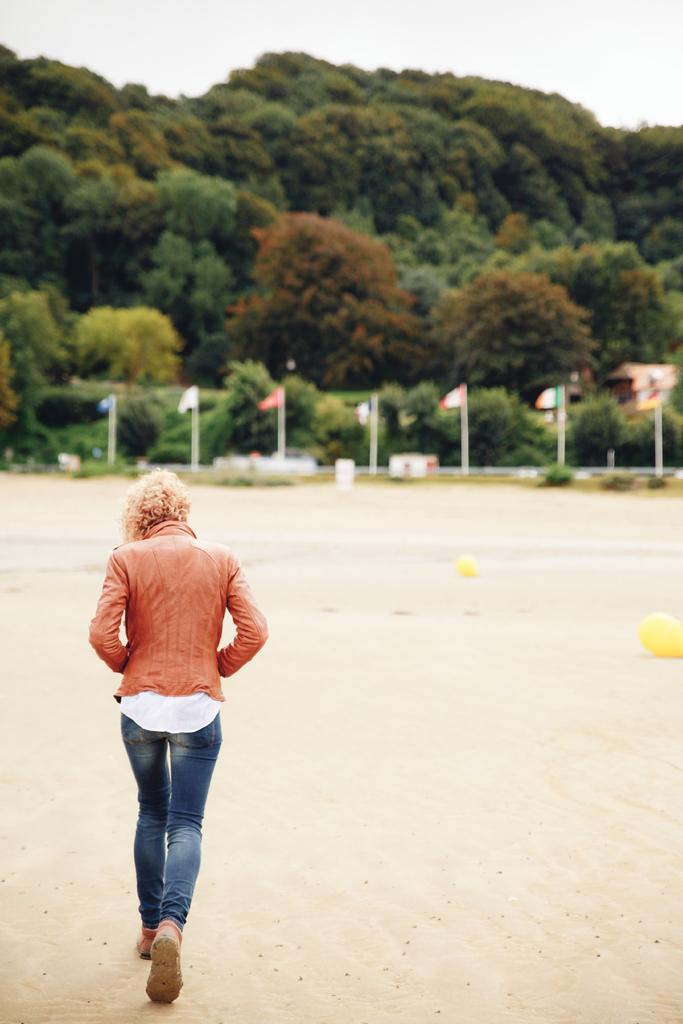What is happening in the foreground of the image? There is a person walking in the foreground of the image. What can be seen in the background of the image? There are trees in the background of the image. What additional elements are present in the image? There are flags visible in the image. What type of milk is being served in the room in the image? There is no room or milk present in the image; it features a person walking with trees and flags in the background. Can you see any pigs in the image? There are no pigs present in the image. 